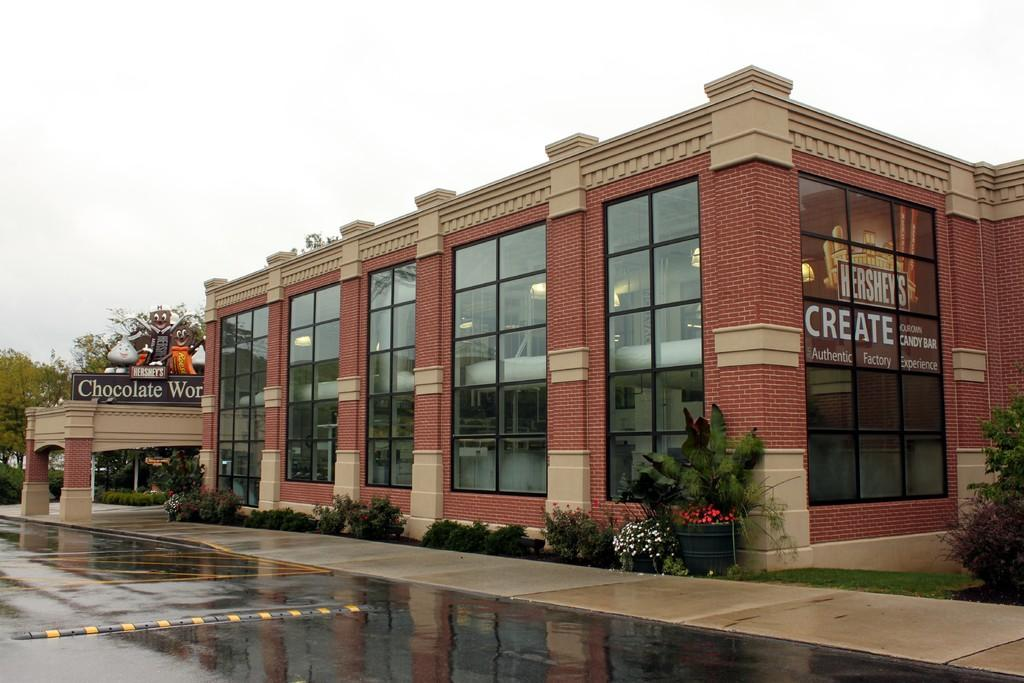Where was the image taken? The image is clicked outside. What is the main subject in the middle of the image? There is a building in the middle of the image. What type of vegetation can be seen in the middle of the image? There are bushes in the middle of the image. What type of vegetation can be seen on the left side of the image? There are trees on the left side of the image. What is visible at the top of the image? The sky is visible at the top of the image. What type of cord is hanging from the tree on the left side of the image? There is no cord hanging from the tree in the image; only trees are present on the left side. 